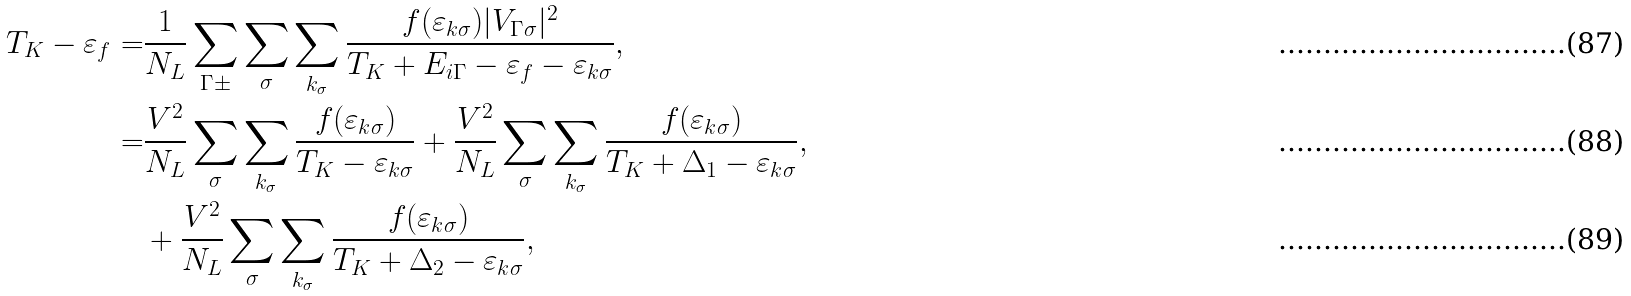<formula> <loc_0><loc_0><loc_500><loc_500>T _ { K } - \varepsilon _ { f } = & \frac { 1 } { N _ { L } } \sum _ { \Gamma \pm } \sum _ { \sigma } \sum _ { { k } _ { \sigma } } \frac { f ( \varepsilon _ { { k } \sigma } ) | V _ { \Gamma \sigma } | ^ { 2 } } { T _ { K } + E _ { i \Gamma } - \varepsilon _ { f } - \varepsilon _ { { k } \sigma } } , \\ = & \frac { V ^ { 2 } } { N _ { L } } \sum _ { \sigma } \sum _ { { k } _ { \sigma } } \frac { f ( \varepsilon _ { { k } \sigma } ) } { T _ { K } - \varepsilon _ { { k } \sigma } } + \frac { V ^ { 2 } } { N _ { L } } \sum _ { \sigma } \sum _ { { k } _ { \sigma } } \frac { f ( \varepsilon _ { { k } \sigma } ) } { T _ { K } + \Delta _ { 1 } - \varepsilon _ { { k } \sigma } } , \\ & + \frac { V ^ { 2 } } { N _ { L } } \sum _ { \sigma } \sum _ { { k } _ { \sigma } } \frac { f ( \varepsilon _ { { k } \sigma } ) } { T _ { K } + \Delta _ { 2 } - \varepsilon _ { { k } \sigma } } ,</formula> 